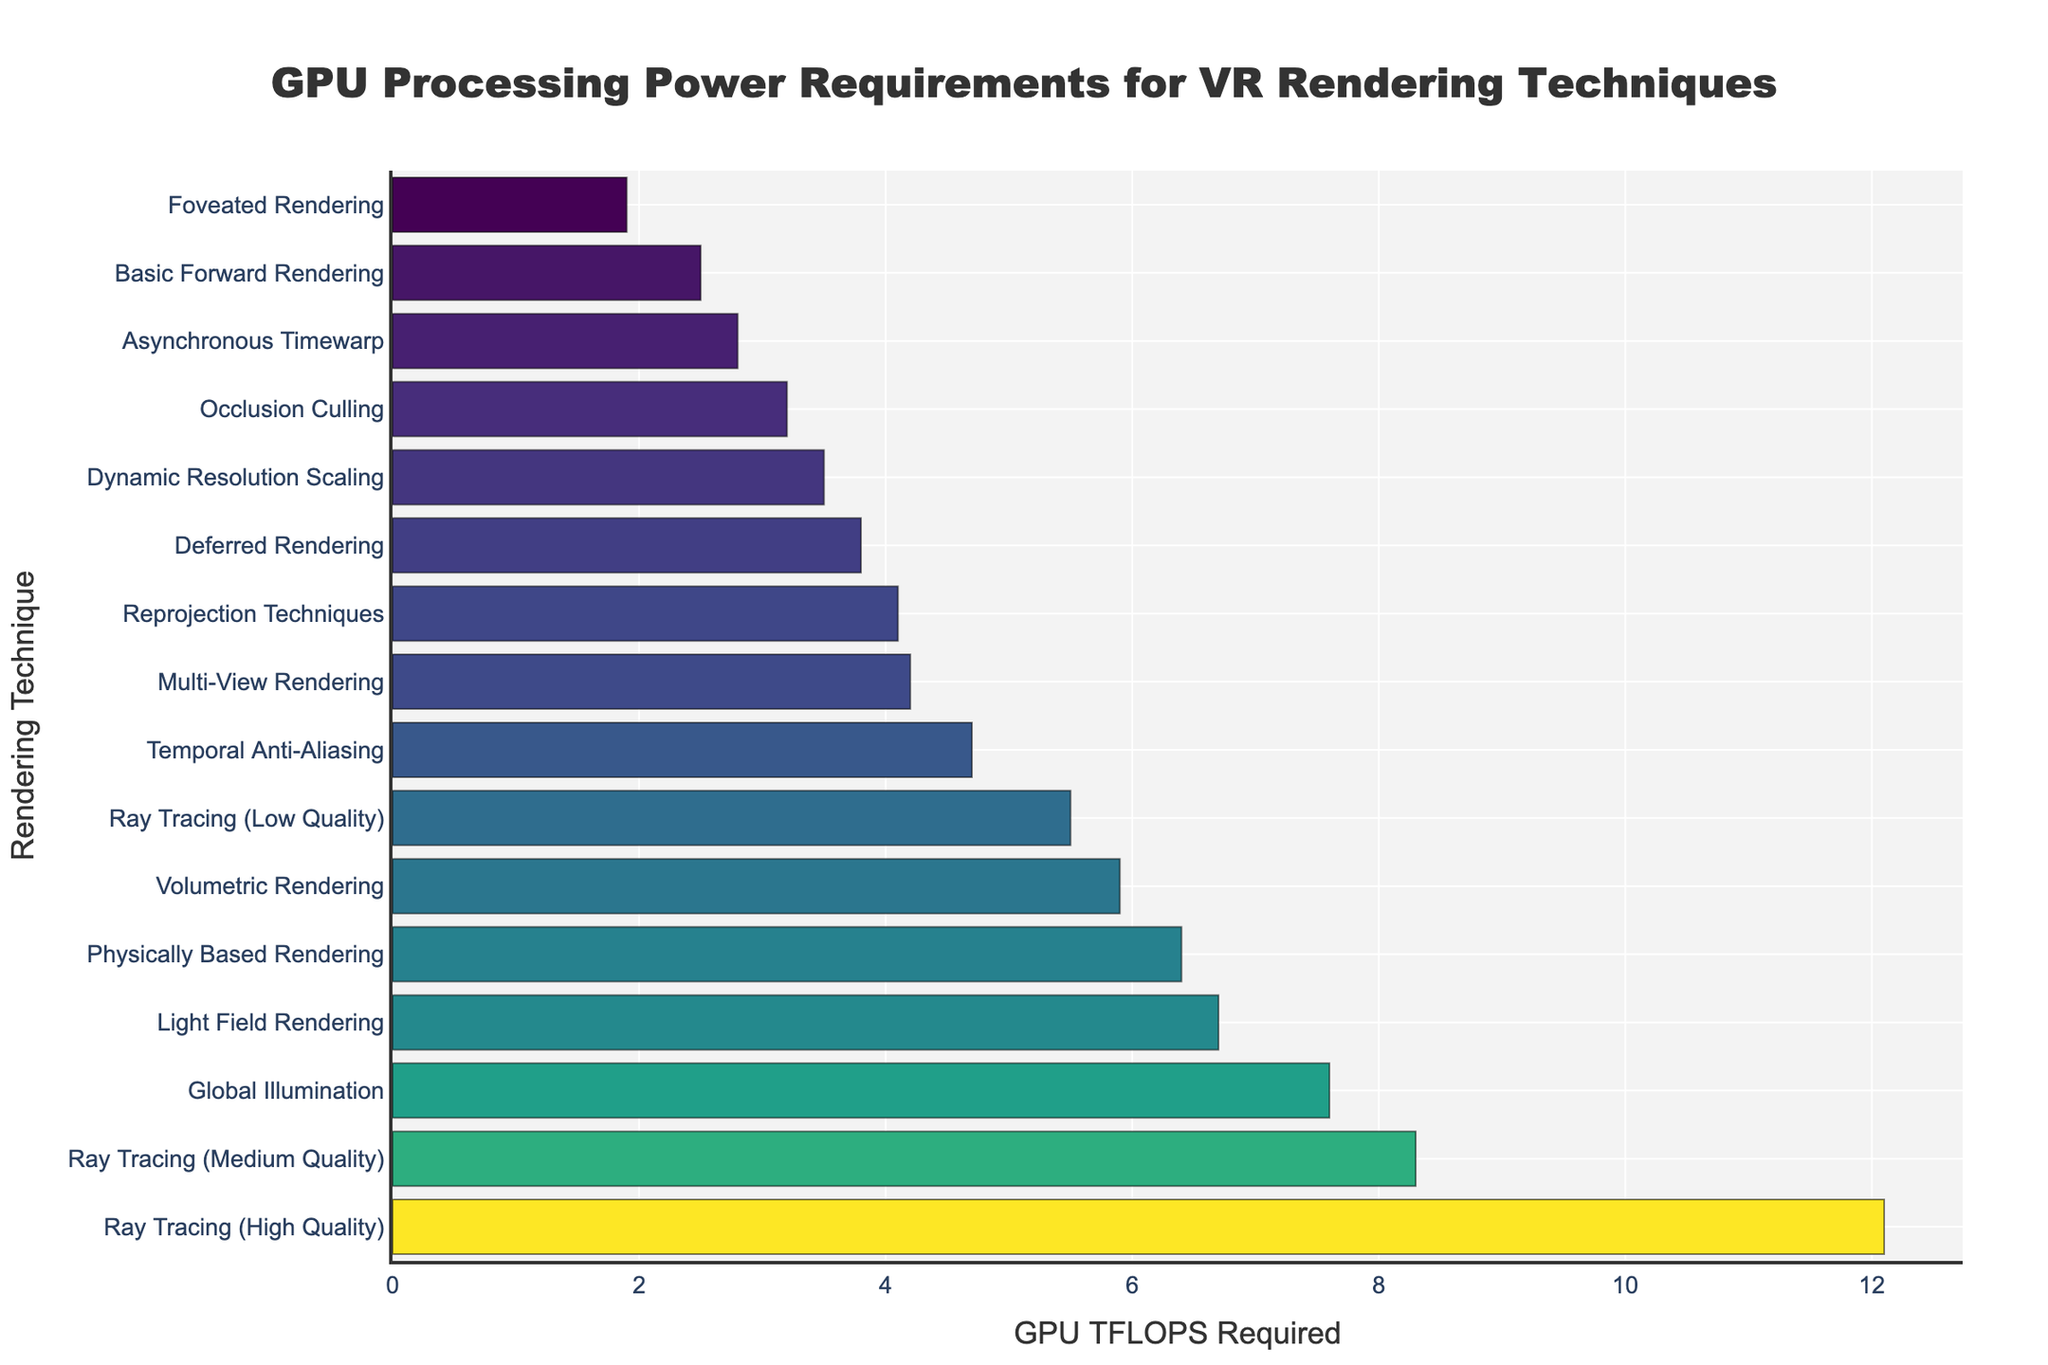Which rendering technique requires the highest GPU processing power? Look for the bar with the greatest length on the plot. This corresponds to "Ray Tracing (High Quality)" with 12.1 TFLOPS.
Answer: Ray Tracing (High Quality) How much more GPU power does Ray Tracing (High Quality) require compared to Foveated Rendering? Find the values for both techniques and subtract the smaller from the larger. Ray Tracing (High Quality) needs 12.1 TFLOPS, and Foveated Rendering needs 1.9 TFLOPS. The difference is 12.1 - 1.9 = 10.2 TFLOPS.
Answer: 10.2 TFLOPS Which rendering technique requires less GPU power: Deferred Rendering or Temporal Anti-Aliasing? Compare the lengths of the bars for Deferred Rendering and Temporal Anti-Aliasing. Deferred Rendering requires 3.8 TFLOPS, while Temporal Anti-Aliasing requires 4.7 TFLOPS. Deferred Rendering needs less.
Answer: Deferred Rendering What is the total GPU power required for Asynchronous Timewarp, Reprojection Techniques, and Occlusion Culling? Sum the values for these three techniques: Asynchronous Timewarp (2.8 TFLOPS), Reprojection Techniques (4.1 TFLOPS), and Occlusion Culling (3.2 TFLOPS). 2.8 + 4.1 + 3.2 = 10.1 TFLOPS.
Answer: 10.1 TFLOPS Which techniques have a GPU requirement between 4.0 and 6.0 TFLOPS? Identify the bars that fall within this range on the x-axis. These are Reprojection Techniques (4.1), Temporal Anti-Aliasing (4.7), Volumetric Rendering (5.9), and Ray Tracing (Low Quality) (5.5).
Answer: Reprojection Techniques, Temporal Anti-Aliasing, Volumetric Rendering, Ray Tracing (Low Quality) What is the median GPU power required among all the rendering techniques listed? List all GPU TFLOPS values and find the median. Values: 1.9, 2.5, 2.8, 3.2, 3.5, 3.8, 4.1, 4.2, 4.7, 5.5, 5.9, 6.4, 6.7, 7.6, 8.3, 12.1. The median is the average of the 8th and 9th values: (4.7 + 5.5) / 2 = 5.1.
Answer: 5.1 TFLOPS Is the GPU power required for Dynamic Resolution Scaling greater than Occlusion Culling but less than Physically Based Rendering? Check the values: Dynamic Resolution Scaling (3.5 TFLOPS), Occlusion Culling (3.2 TFLOPS), Physically Based Rendering (6.4 TFLOPS). 3.5 is greater than 3.2 and less than 6.4.
Answer: Yes Which technique has the nearest GPU requirement to Deferred Rendering? Find the GPU TFLOPS of Deferred Rendering (3.8) and see which technique has a close value. Occlusion Culling (3.2 TFLOPS) is the nearest.
Answer: Occlusion Culling What is the average GPU processing power for the three techniques that require the most GPU power? Identify the three techniques with the highest values: Ray Tracing (High Quality) (12.1 TFLOPS), Ray Tracing (Medium Quality) (8.3 TFLOPS), and Global Illumination (7.6 TFLOPS). Calculate the average: (12.1 + 8.3 + 7.6) / 3 ≈ 9.33 TFLOPS.
Answer: 9.33 TFLOPS Compare GPU requirements for Ray Tracing (Low Quality) and Volumetric Rendering. Which one requires more processing power and by how much? Ray Tracing (Low Quality) requires 5.5 TFLOPS, and Volumetric Rendering requires 5.9 TFLOPS. Volumetric Rendering requires more by 5.9 - 5.5 = 0.4 TFLOPS.
Answer: Volumetric Rendering, by 0.4 TFLOPS 